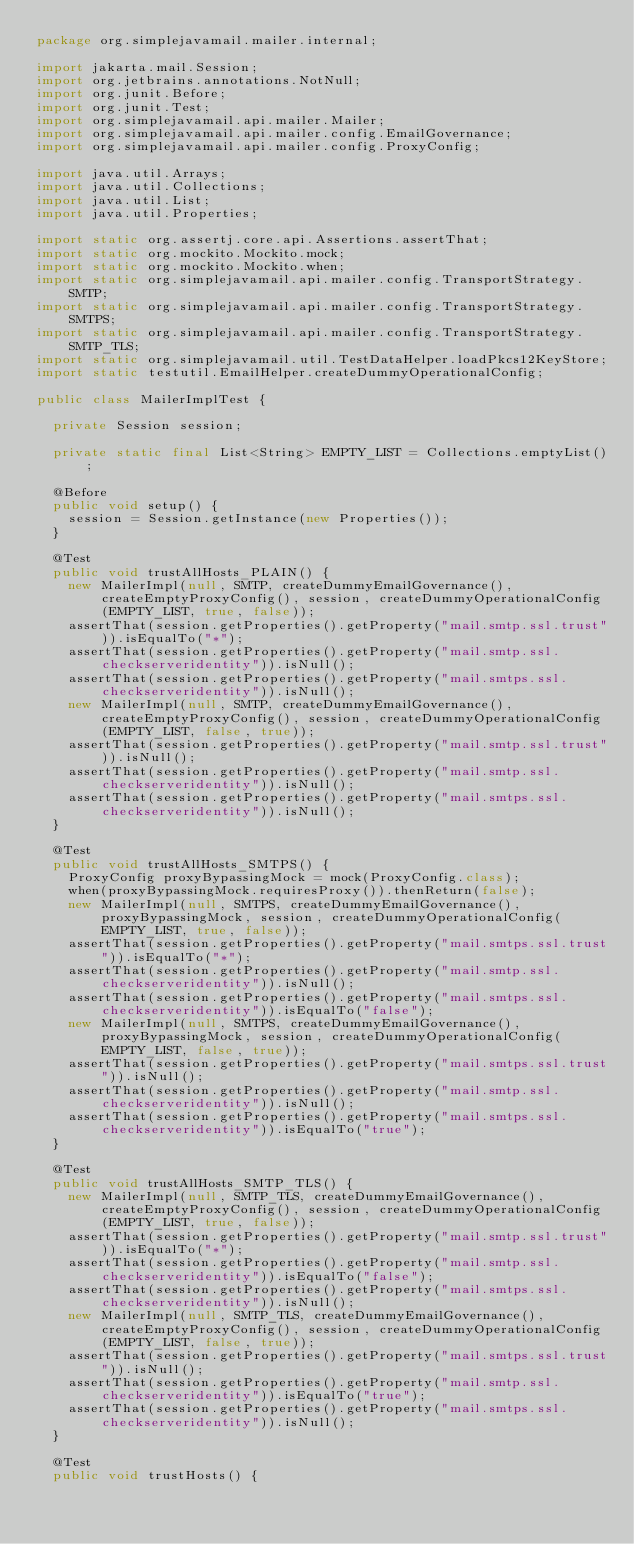<code> <loc_0><loc_0><loc_500><loc_500><_Java_>package org.simplejavamail.mailer.internal;

import jakarta.mail.Session;
import org.jetbrains.annotations.NotNull;
import org.junit.Before;
import org.junit.Test;
import org.simplejavamail.api.mailer.Mailer;
import org.simplejavamail.api.mailer.config.EmailGovernance;
import org.simplejavamail.api.mailer.config.ProxyConfig;

import java.util.Arrays;
import java.util.Collections;
import java.util.List;
import java.util.Properties;

import static org.assertj.core.api.Assertions.assertThat;
import static org.mockito.Mockito.mock;
import static org.mockito.Mockito.when;
import static org.simplejavamail.api.mailer.config.TransportStrategy.SMTP;
import static org.simplejavamail.api.mailer.config.TransportStrategy.SMTPS;
import static org.simplejavamail.api.mailer.config.TransportStrategy.SMTP_TLS;
import static org.simplejavamail.util.TestDataHelper.loadPkcs12KeyStore;
import static testutil.EmailHelper.createDummyOperationalConfig;

public class MailerImplTest {
	
	private Session session;
	
	private static final List<String> EMPTY_LIST = Collections.emptyList();
	
	@Before
	public void setup() {
		session = Session.getInstance(new Properties());
	}
	
	@Test
	public void trustAllHosts_PLAIN() {
		new MailerImpl(null, SMTP, createDummyEmailGovernance(), createEmptyProxyConfig(), session, createDummyOperationalConfig(EMPTY_LIST, true, false));
		assertThat(session.getProperties().getProperty("mail.smtp.ssl.trust")).isEqualTo("*");
		assertThat(session.getProperties().getProperty("mail.smtp.ssl.checkserveridentity")).isNull();
		assertThat(session.getProperties().getProperty("mail.smtps.ssl.checkserveridentity")).isNull();
		new MailerImpl(null, SMTP, createDummyEmailGovernance(), createEmptyProxyConfig(), session, createDummyOperationalConfig(EMPTY_LIST, false, true));
		assertThat(session.getProperties().getProperty("mail.smtp.ssl.trust")).isNull();
		assertThat(session.getProperties().getProperty("mail.smtp.ssl.checkserveridentity")).isNull();
		assertThat(session.getProperties().getProperty("mail.smtps.ssl.checkserveridentity")).isNull();
	}
	
	@Test
	public void trustAllHosts_SMTPS() {
		ProxyConfig proxyBypassingMock = mock(ProxyConfig.class);
		when(proxyBypassingMock.requiresProxy()).thenReturn(false);
		new MailerImpl(null, SMTPS, createDummyEmailGovernance(), proxyBypassingMock, session, createDummyOperationalConfig(EMPTY_LIST, true, false));
		assertThat(session.getProperties().getProperty("mail.smtps.ssl.trust")).isEqualTo("*");
		assertThat(session.getProperties().getProperty("mail.smtp.ssl.checkserveridentity")).isNull();
		assertThat(session.getProperties().getProperty("mail.smtps.ssl.checkserveridentity")).isEqualTo("false");
		new MailerImpl(null, SMTPS, createDummyEmailGovernance(), proxyBypassingMock, session, createDummyOperationalConfig(EMPTY_LIST, false, true));
		assertThat(session.getProperties().getProperty("mail.smtps.ssl.trust")).isNull();
		assertThat(session.getProperties().getProperty("mail.smtp.ssl.checkserveridentity")).isNull();
		assertThat(session.getProperties().getProperty("mail.smtps.ssl.checkserveridentity")).isEqualTo("true");
	}

	@Test
	public void trustAllHosts_SMTP_TLS() {
		new MailerImpl(null, SMTP_TLS, createDummyEmailGovernance(), createEmptyProxyConfig(), session, createDummyOperationalConfig(EMPTY_LIST, true, false));
		assertThat(session.getProperties().getProperty("mail.smtp.ssl.trust")).isEqualTo("*");
		assertThat(session.getProperties().getProperty("mail.smtp.ssl.checkserveridentity")).isEqualTo("false");
		assertThat(session.getProperties().getProperty("mail.smtps.ssl.checkserveridentity")).isNull();
		new MailerImpl(null, SMTP_TLS, createDummyEmailGovernance(), createEmptyProxyConfig(), session, createDummyOperationalConfig(EMPTY_LIST, false, true));
		assertThat(session.getProperties().getProperty("mail.smtps.ssl.trust")).isNull();
		assertThat(session.getProperties().getProperty("mail.smtp.ssl.checkserveridentity")).isEqualTo("true");
		assertThat(session.getProperties().getProperty("mail.smtps.ssl.checkserveridentity")).isNull();
	}
	
	@Test
	public void trustHosts() {</code> 